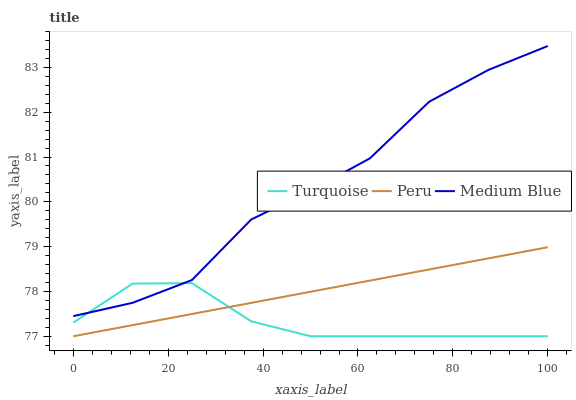Does Turquoise have the minimum area under the curve?
Answer yes or no. Yes. Does Medium Blue have the maximum area under the curve?
Answer yes or no. Yes. Does Peru have the minimum area under the curve?
Answer yes or no. No. Does Peru have the maximum area under the curve?
Answer yes or no. No. Is Peru the smoothest?
Answer yes or no. Yes. Is Medium Blue the roughest?
Answer yes or no. Yes. Is Medium Blue the smoothest?
Answer yes or no. No. Is Peru the roughest?
Answer yes or no. No. Does Turquoise have the lowest value?
Answer yes or no. Yes. Does Medium Blue have the lowest value?
Answer yes or no. No. Does Medium Blue have the highest value?
Answer yes or no. Yes. Does Peru have the highest value?
Answer yes or no. No. Is Peru less than Medium Blue?
Answer yes or no. Yes. Is Medium Blue greater than Peru?
Answer yes or no. Yes. Does Turquoise intersect Medium Blue?
Answer yes or no. Yes. Is Turquoise less than Medium Blue?
Answer yes or no. No. Is Turquoise greater than Medium Blue?
Answer yes or no. No. Does Peru intersect Medium Blue?
Answer yes or no. No. 